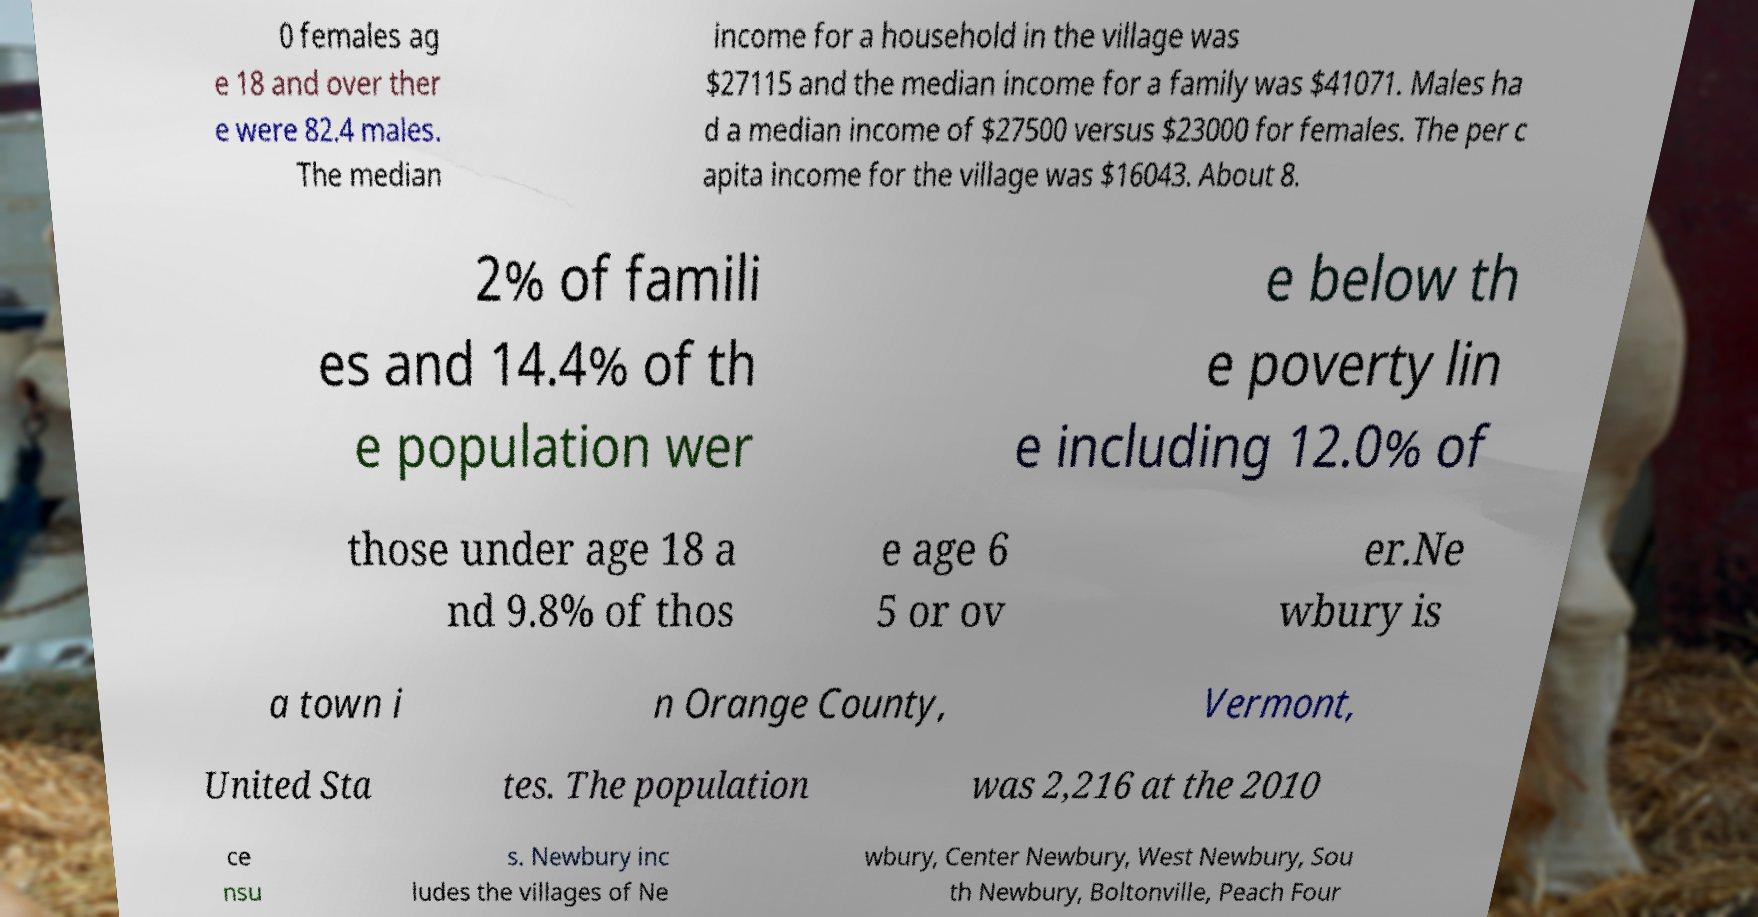There's text embedded in this image that I need extracted. Can you transcribe it verbatim? 0 females ag e 18 and over ther e were 82.4 males. The median income for a household in the village was $27115 and the median income for a family was $41071. Males ha d a median income of $27500 versus $23000 for females. The per c apita income for the village was $16043. About 8. 2% of famili es and 14.4% of th e population wer e below th e poverty lin e including 12.0% of those under age 18 a nd 9.8% of thos e age 6 5 or ov er.Ne wbury is a town i n Orange County, Vermont, United Sta tes. The population was 2,216 at the 2010 ce nsu s. Newbury inc ludes the villages of Ne wbury, Center Newbury, West Newbury, Sou th Newbury, Boltonville, Peach Four 